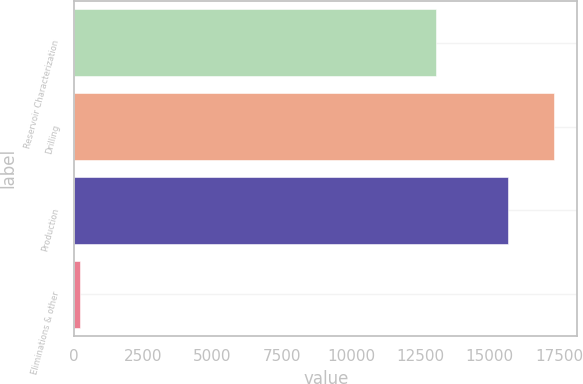Convert chart to OTSL. <chart><loc_0><loc_0><loc_500><loc_500><bar_chart><fcel>Reservoir Characterization<fcel>Drilling<fcel>Production<fcel>Eliminations & other<nl><fcel>13050<fcel>17303<fcel>15646<fcel>222<nl></chart> 